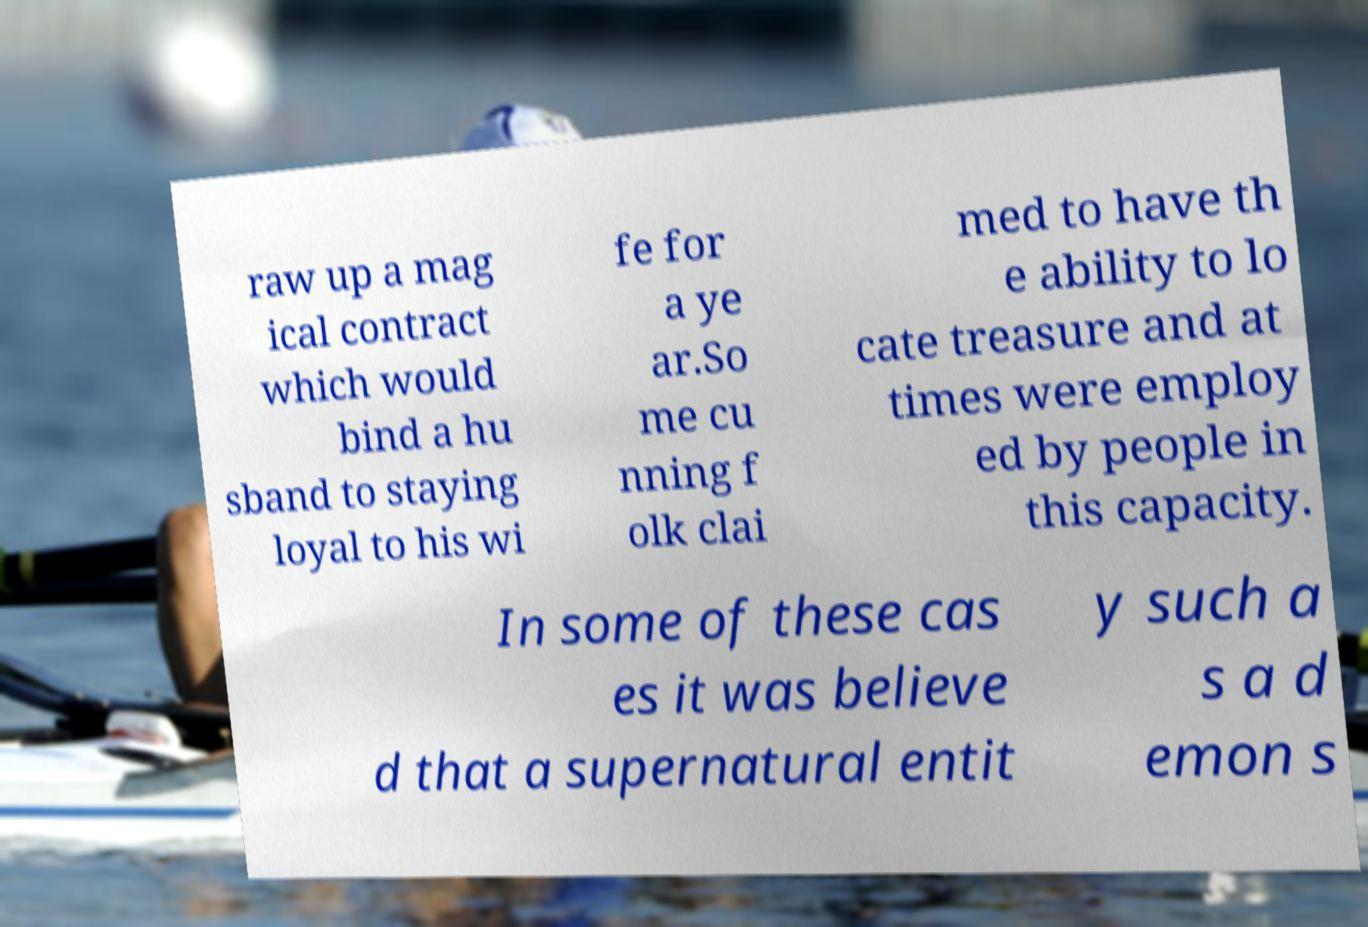I need the written content from this picture converted into text. Can you do that? raw up a mag ical contract which would bind a hu sband to staying loyal to his wi fe for a ye ar.So me cu nning f olk clai med to have th e ability to lo cate treasure and at times were employ ed by people in this capacity. In some of these cas es it was believe d that a supernatural entit y such a s a d emon s 